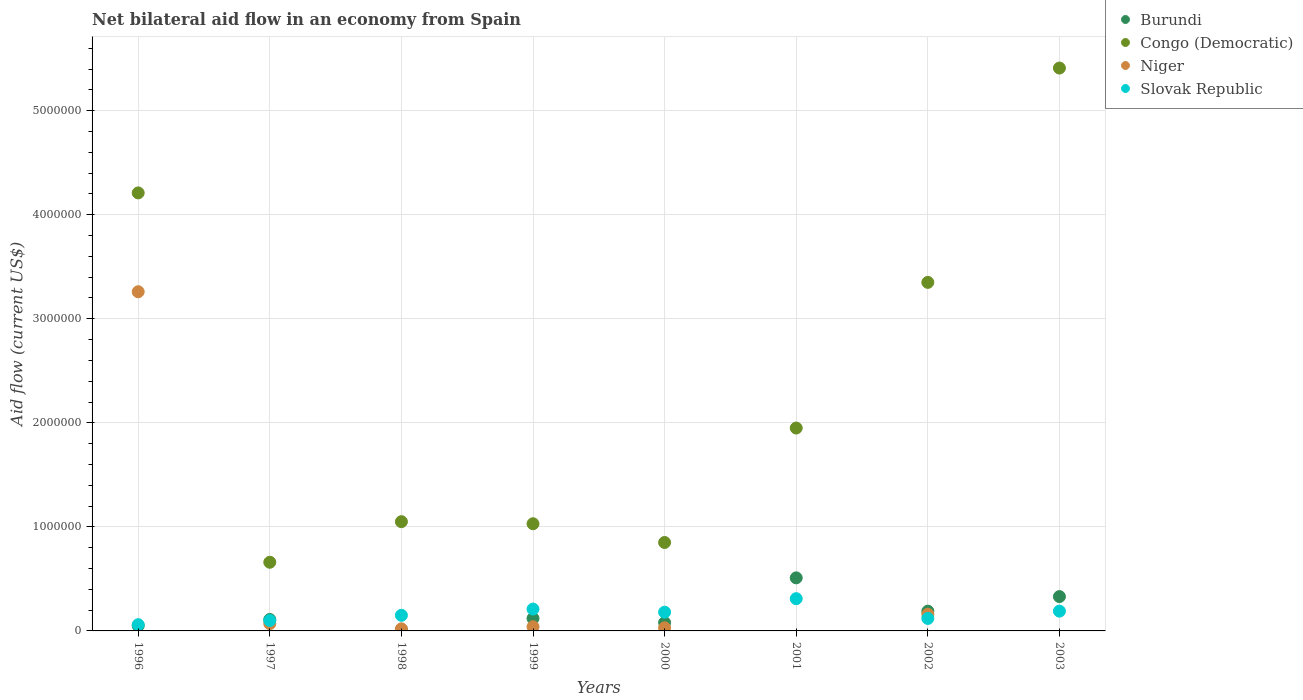Is the number of dotlines equal to the number of legend labels?
Your answer should be very brief. No. Across all years, what is the maximum net bilateral aid flow in Niger?
Offer a terse response. 3.26e+06. What is the total net bilateral aid flow in Congo (Democratic) in the graph?
Offer a very short reply. 1.85e+07. What is the difference between the net bilateral aid flow in Congo (Democratic) in 1998 and that in 1999?
Offer a terse response. 2.00e+04. What is the average net bilateral aid flow in Slovak Republic per year?
Provide a succinct answer. 1.65e+05. In the year 2002, what is the difference between the net bilateral aid flow in Congo (Democratic) and net bilateral aid flow in Burundi?
Your answer should be compact. 3.16e+06. What is the ratio of the net bilateral aid flow in Niger in 1998 to that in 2000?
Give a very brief answer. 0.67. Is the net bilateral aid flow in Slovak Republic in 1996 less than that in 1997?
Your answer should be compact. Yes. Is the difference between the net bilateral aid flow in Congo (Democratic) in 1996 and 1997 greater than the difference between the net bilateral aid flow in Burundi in 1996 and 1997?
Provide a short and direct response. Yes. What is the difference between the highest and the second highest net bilateral aid flow in Congo (Democratic)?
Provide a short and direct response. 1.20e+06. What is the difference between the highest and the lowest net bilateral aid flow in Niger?
Provide a succinct answer. 3.26e+06. Is the sum of the net bilateral aid flow in Niger in 1996 and 2000 greater than the maximum net bilateral aid flow in Congo (Democratic) across all years?
Offer a very short reply. No. Is the net bilateral aid flow in Burundi strictly greater than the net bilateral aid flow in Niger over the years?
Your answer should be compact. No. How many dotlines are there?
Make the answer very short. 4. What is the difference between two consecutive major ticks on the Y-axis?
Ensure brevity in your answer.  1.00e+06. Are the values on the major ticks of Y-axis written in scientific E-notation?
Offer a very short reply. No. Does the graph contain grids?
Make the answer very short. Yes. Where does the legend appear in the graph?
Make the answer very short. Top right. How many legend labels are there?
Your answer should be compact. 4. How are the legend labels stacked?
Offer a terse response. Vertical. What is the title of the graph?
Your answer should be very brief. Net bilateral aid flow in an economy from Spain. What is the label or title of the X-axis?
Provide a short and direct response. Years. What is the Aid flow (current US$) in Congo (Democratic) in 1996?
Offer a terse response. 4.21e+06. What is the Aid flow (current US$) of Niger in 1996?
Your answer should be compact. 3.26e+06. What is the Aid flow (current US$) of Niger in 1997?
Make the answer very short. 7.00e+04. What is the Aid flow (current US$) of Slovak Republic in 1997?
Ensure brevity in your answer.  1.00e+05. What is the Aid flow (current US$) in Burundi in 1998?
Offer a terse response. 10000. What is the Aid flow (current US$) of Congo (Democratic) in 1998?
Your answer should be very brief. 1.05e+06. What is the Aid flow (current US$) of Niger in 1998?
Keep it short and to the point. 2.00e+04. What is the Aid flow (current US$) in Burundi in 1999?
Provide a short and direct response. 1.20e+05. What is the Aid flow (current US$) of Congo (Democratic) in 1999?
Give a very brief answer. 1.03e+06. What is the Aid flow (current US$) in Congo (Democratic) in 2000?
Provide a short and direct response. 8.50e+05. What is the Aid flow (current US$) of Burundi in 2001?
Ensure brevity in your answer.  5.10e+05. What is the Aid flow (current US$) of Congo (Democratic) in 2001?
Your answer should be very brief. 1.95e+06. What is the Aid flow (current US$) of Niger in 2001?
Provide a succinct answer. 0. What is the Aid flow (current US$) in Slovak Republic in 2001?
Keep it short and to the point. 3.10e+05. What is the Aid flow (current US$) of Burundi in 2002?
Provide a succinct answer. 1.90e+05. What is the Aid flow (current US$) of Congo (Democratic) in 2002?
Your answer should be very brief. 3.35e+06. What is the Aid flow (current US$) in Niger in 2002?
Your response must be concise. 1.60e+05. What is the Aid flow (current US$) in Slovak Republic in 2002?
Offer a very short reply. 1.20e+05. What is the Aid flow (current US$) of Burundi in 2003?
Keep it short and to the point. 3.30e+05. What is the Aid flow (current US$) of Congo (Democratic) in 2003?
Offer a very short reply. 5.41e+06. Across all years, what is the maximum Aid flow (current US$) in Burundi?
Offer a very short reply. 5.10e+05. Across all years, what is the maximum Aid flow (current US$) of Congo (Democratic)?
Your response must be concise. 5.41e+06. Across all years, what is the maximum Aid flow (current US$) in Niger?
Provide a short and direct response. 3.26e+06. Across all years, what is the maximum Aid flow (current US$) of Slovak Republic?
Give a very brief answer. 3.10e+05. Across all years, what is the minimum Aid flow (current US$) in Burundi?
Give a very brief answer. 10000. Across all years, what is the minimum Aid flow (current US$) in Congo (Democratic)?
Offer a very short reply. 6.60e+05. Across all years, what is the minimum Aid flow (current US$) in Slovak Republic?
Your response must be concise. 6.00e+04. What is the total Aid flow (current US$) in Burundi in the graph?
Your answer should be very brief. 1.40e+06. What is the total Aid flow (current US$) of Congo (Democratic) in the graph?
Your answer should be compact. 1.85e+07. What is the total Aid flow (current US$) of Niger in the graph?
Your answer should be compact. 3.58e+06. What is the total Aid flow (current US$) of Slovak Republic in the graph?
Offer a very short reply. 1.32e+06. What is the difference between the Aid flow (current US$) of Congo (Democratic) in 1996 and that in 1997?
Provide a short and direct response. 3.55e+06. What is the difference between the Aid flow (current US$) of Niger in 1996 and that in 1997?
Your answer should be compact. 3.19e+06. What is the difference between the Aid flow (current US$) in Congo (Democratic) in 1996 and that in 1998?
Your answer should be compact. 3.16e+06. What is the difference between the Aid flow (current US$) in Niger in 1996 and that in 1998?
Make the answer very short. 3.24e+06. What is the difference between the Aid flow (current US$) of Slovak Republic in 1996 and that in 1998?
Give a very brief answer. -9.00e+04. What is the difference between the Aid flow (current US$) in Congo (Democratic) in 1996 and that in 1999?
Provide a short and direct response. 3.18e+06. What is the difference between the Aid flow (current US$) of Niger in 1996 and that in 1999?
Provide a short and direct response. 3.22e+06. What is the difference between the Aid flow (current US$) in Congo (Democratic) in 1996 and that in 2000?
Keep it short and to the point. 3.36e+06. What is the difference between the Aid flow (current US$) of Niger in 1996 and that in 2000?
Provide a short and direct response. 3.23e+06. What is the difference between the Aid flow (current US$) of Burundi in 1996 and that in 2001?
Your answer should be very brief. -4.60e+05. What is the difference between the Aid flow (current US$) of Congo (Democratic) in 1996 and that in 2001?
Give a very brief answer. 2.26e+06. What is the difference between the Aid flow (current US$) in Burundi in 1996 and that in 2002?
Make the answer very short. -1.40e+05. What is the difference between the Aid flow (current US$) of Congo (Democratic) in 1996 and that in 2002?
Make the answer very short. 8.60e+05. What is the difference between the Aid flow (current US$) of Niger in 1996 and that in 2002?
Offer a terse response. 3.10e+06. What is the difference between the Aid flow (current US$) in Slovak Republic in 1996 and that in 2002?
Make the answer very short. -6.00e+04. What is the difference between the Aid flow (current US$) in Burundi in 1996 and that in 2003?
Provide a succinct answer. -2.80e+05. What is the difference between the Aid flow (current US$) of Congo (Democratic) in 1996 and that in 2003?
Keep it short and to the point. -1.20e+06. What is the difference between the Aid flow (current US$) in Slovak Republic in 1996 and that in 2003?
Provide a short and direct response. -1.30e+05. What is the difference between the Aid flow (current US$) of Congo (Democratic) in 1997 and that in 1998?
Ensure brevity in your answer.  -3.90e+05. What is the difference between the Aid flow (current US$) of Niger in 1997 and that in 1998?
Your answer should be compact. 5.00e+04. What is the difference between the Aid flow (current US$) in Burundi in 1997 and that in 1999?
Provide a short and direct response. -10000. What is the difference between the Aid flow (current US$) of Congo (Democratic) in 1997 and that in 1999?
Offer a very short reply. -3.70e+05. What is the difference between the Aid flow (current US$) of Niger in 1997 and that in 1999?
Ensure brevity in your answer.  3.00e+04. What is the difference between the Aid flow (current US$) in Slovak Republic in 1997 and that in 1999?
Give a very brief answer. -1.10e+05. What is the difference between the Aid flow (current US$) in Burundi in 1997 and that in 2001?
Your answer should be compact. -4.00e+05. What is the difference between the Aid flow (current US$) of Congo (Democratic) in 1997 and that in 2001?
Your answer should be very brief. -1.29e+06. What is the difference between the Aid flow (current US$) of Slovak Republic in 1997 and that in 2001?
Offer a terse response. -2.10e+05. What is the difference between the Aid flow (current US$) in Congo (Democratic) in 1997 and that in 2002?
Your response must be concise. -2.69e+06. What is the difference between the Aid flow (current US$) in Niger in 1997 and that in 2002?
Offer a terse response. -9.00e+04. What is the difference between the Aid flow (current US$) in Slovak Republic in 1997 and that in 2002?
Provide a succinct answer. -2.00e+04. What is the difference between the Aid flow (current US$) in Burundi in 1997 and that in 2003?
Your response must be concise. -2.20e+05. What is the difference between the Aid flow (current US$) of Congo (Democratic) in 1997 and that in 2003?
Your response must be concise. -4.75e+06. What is the difference between the Aid flow (current US$) of Congo (Democratic) in 1998 and that in 1999?
Your answer should be compact. 2.00e+04. What is the difference between the Aid flow (current US$) in Niger in 1998 and that in 1999?
Offer a very short reply. -2.00e+04. What is the difference between the Aid flow (current US$) in Slovak Republic in 1998 and that in 1999?
Ensure brevity in your answer.  -6.00e+04. What is the difference between the Aid flow (current US$) of Congo (Democratic) in 1998 and that in 2000?
Make the answer very short. 2.00e+05. What is the difference between the Aid flow (current US$) in Niger in 1998 and that in 2000?
Offer a terse response. -10000. What is the difference between the Aid flow (current US$) of Burundi in 1998 and that in 2001?
Provide a succinct answer. -5.00e+05. What is the difference between the Aid flow (current US$) in Congo (Democratic) in 1998 and that in 2001?
Ensure brevity in your answer.  -9.00e+05. What is the difference between the Aid flow (current US$) in Slovak Republic in 1998 and that in 2001?
Your response must be concise. -1.60e+05. What is the difference between the Aid flow (current US$) in Congo (Democratic) in 1998 and that in 2002?
Offer a terse response. -2.30e+06. What is the difference between the Aid flow (current US$) in Niger in 1998 and that in 2002?
Offer a very short reply. -1.40e+05. What is the difference between the Aid flow (current US$) in Burundi in 1998 and that in 2003?
Keep it short and to the point. -3.20e+05. What is the difference between the Aid flow (current US$) of Congo (Democratic) in 1998 and that in 2003?
Your answer should be very brief. -4.36e+06. What is the difference between the Aid flow (current US$) of Slovak Republic in 1998 and that in 2003?
Ensure brevity in your answer.  -4.00e+04. What is the difference between the Aid flow (current US$) in Congo (Democratic) in 1999 and that in 2000?
Your response must be concise. 1.80e+05. What is the difference between the Aid flow (current US$) in Niger in 1999 and that in 2000?
Ensure brevity in your answer.  10000. What is the difference between the Aid flow (current US$) in Slovak Republic in 1999 and that in 2000?
Provide a succinct answer. 3.00e+04. What is the difference between the Aid flow (current US$) in Burundi in 1999 and that in 2001?
Offer a terse response. -3.90e+05. What is the difference between the Aid flow (current US$) of Congo (Democratic) in 1999 and that in 2001?
Keep it short and to the point. -9.20e+05. What is the difference between the Aid flow (current US$) in Congo (Democratic) in 1999 and that in 2002?
Provide a short and direct response. -2.32e+06. What is the difference between the Aid flow (current US$) in Niger in 1999 and that in 2002?
Your answer should be very brief. -1.20e+05. What is the difference between the Aid flow (current US$) in Slovak Republic in 1999 and that in 2002?
Give a very brief answer. 9.00e+04. What is the difference between the Aid flow (current US$) of Congo (Democratic) in 1999 and that in 2003?
Your answer should be very brief. -4.38e+06. What is the difference between the Aid flow (current US$) in Burundi in 2000 and that in 2001?
Your answer should be compact. -4.30e+05. What is the difference between the Aid flow (current US$) in Congo (Democratic) in 2000 and that in 2001?
Your response must be concise. -1.10e+06. What is the difference between the Aid flow (current US$) of Slovak Republic in 2000 and that in 2001?
Make the answer very short. -1.30e+05. What is the difference between the Aid flow (current US$) in Congo (Democratic) in 2000 and that in 2002?
Make the answer very short. -2.50e+06. What is the difference between the Aid flow (current US$) of Niger in 2000 and that in 2002?
Offer a terse response. -1.30e+05. What is the difference between the Aid flow (current US$) of Burundi in 2000 and that in 2003?
Your answer should be very brief. -2.50e+05. What is the difference between the Aid flow (current US$) in Congo (Democratic) in 2000 and that in 2003?
Give a very brief answer. -4.56e+06. What is the difference between the Aid flow (current US$) of Congo (Democratic) in 2001 and that in 2002?
Give a very brief answer. -1.40e+06. What is the difference between the Aid flow (current US$) of Slovak Republic in 2001 and that in 2002?
Offer a very short reply. 1.90e+05. What is the difference between the Aid flow (current US$) of Burundi in 2001 and that in 2003?
Your response must be concise. 1.80e+05. What is the difference between the Aid flow (current US$) in Congo (Democratic) in 2001 and that in 2003?
Keep it short and to the point. -3.46e+06. What is the difference between the Aid flow (current US$) in Burundi in 2002 and that in 2003?
Keep it short and to the point. -1.40e+05. What is the difference between the Aid flow (current US$) in Congo (Democratic) in 2002 and that in 2003?
Your answer should be very brief. -2.06e+06. What is the difference between the Aid flow (current US$) of Burundi in 1996 and the Aid flow (current US$) of Congo (Democratic) in 1997?
Your answer should be compact. -6.10e+05. What is the difference between the Aid flow (current US$) of Burundi in 1996 and the Aid flow (current US$) of Niger in 1997?
Keep it short and to the point. -2.00e+04. What is the difference between the Aid flow (current US$) of Burundi in 1996 and the Aid flow (current US$) of Slovak Republic in 1997?
Ensure brevity in your answer.  -5.00e+04. What is the difference between the Aid flow (current US$) in Congo (Democratic) in 1996 and the Aid flow (current US$) in Niger in 1997?
Your response must be concise. 4.14e+06. What is the difference between the Aid flow (current US$) of Congo (Democratic) in 1996 and the Aid flow (current US$) of Slovak Republic in 1997?
Your answer should be compact. 4.11e+06. What is the difference between the Aid flow (current US$) of Niger in 1996 and the Aid flow (current US$) of Slovak Republic in 1997?
Your answer should be very brief. 3.16e+06. What is the difference between the Aid flow (current US$) of Burundi in 1996 and the Aid flow (current US$) of Congo (Democratic) in 1998?
Your answer should be very brief. -1.00e+06. What is the difference between the Aid flow (current US$) of Congo (Democratic) in 1996 and the Aid flow (current US$) of Niger in 1998?
Make the answer very short. 4.19e+06. What is the difference between the Aid flow (current US$) in Congo (Democratic) in 1996 and the Aid flow (current US$) in Slovak Republic in 1998?
Offer a terse response. 4.06e+06. What is the difference between the Aid flow (current US$) of Niger in 1996 and the Aid flow (current US$) of Slovak Republic in 1998?
Provide a succinct answer. 3.11e+06. What is the difference between the Aid flow (current US$) in Burundi in 1996 and the Aid flow (current US$) in Congo (Democratic) in 1999?
Ensure brevity in your answer.  -9.80e+05. What is the difference between the Aid flow (current US$) in Burundi in 1996 and the Aid flow (current US$) in Slovak Republic in 1999?
Ensure brevity in your answer.  -1.60e+05. What is the difference between the Aid flow (current US$) of Congo (Democratic) in 1996 and the Aid flow (current US$) of Niger in 1999?
Provide a succinct answer. 4.17e+06. What is the difference between the Aid flow (current US$) of Niger in 1996 and the Aid flow (current US$) of Slovak Republic in 1999?
Your answer should be compact. 3.05e+06. What is the difference between the Aid flow (current US$) in Burundi in 1996 and the Aid flow (current US$) in Congo (Democratic) in 2000?
Provide a short and direct response. -8.00e+05. What is the difference between the Aid flow (current US$) in Congo (Democratic) in 1996 and the Aid flow (current US$) in Niger in 2000?
Offer a terse response. 4.18e+06. What is the difference between the Aid flow (current US$) in Congo (Democratic) in 1996 and the Aid flow (current US$) in Slovak Republic in 2000?
Your answer should be compact. 4.03e+06. What is the difference between the Aid flow (current US$) of Niger in 1996 and the Aid flow (current US$) of Slovak Republic in 2000?
Provide a succinct answer. 3.08e+06. What is the difference between the Aid flow (current US$) of Burundi in 1996 and the Aid flow (current US$) of Congo (Democratic) in 2001?
Your response must be concise. -1.90e+06. What is the difference between the Aid flow (current US$) of Congo (Democratic) in 1996 and the Aid flow (current US$) of Slovak Republic in 2001?
Provide a short and direct response. 3.90e+06. What is the difference between the Aid flow (current US$) of Niger in 1996 and the Aid flow (current US$) of Slovak Republic in 2001?
Provide a succinct answer. 2.95e+06. What is the difference between the Aid flow (current US$) of Burundi in 1996 and the Aid flow (current US$) of Congo (Democratic) in 2002?
Keep it short and to the point. -3.30e+06. What is the difference between the Aid flow (current US$) of Burundi in 1996 and the Aid flow (current US$) of Niger in 2002?
Offer a very short reply. -1.10e+05. What is the difference between the Aid flow (current US$) in Congo (Democratic) in 1996 and the Aid flow (current US$) in Niger in 2002?
Your response must be concise. 4.05e+06. What is the difference between the Aid flow (current US$) in Congo (Democratic) in 1996 and the Aid flow (current US$) in Slovak Republic in 2002?
Provide a short and direct response. 4.09e+06. What is the difference between the Aid flow (current US$) of Niger in 1996 and the Aid flow (current US$) of Slovak Republic in 2002?
Provide a short and direct response. 3.14e+06. What is the difference between the Aid flow (current US$) of Burundi in 1996 and the Aid flow (current US$) of Congo (Democratic) in 2003?
Provide a short and direct response. -5.36e+06. What is the difference between the Aid flow (current US$) in Burundi in 1996 and the Aid flow (current US$) in Slovak Republic in 2003?
Your response must be concise. -1.40e+05. What is the difference between the Aid flow (current US$) in Congo (Democratic) in 1996 and the Aid flow (current US$) in Slovak Republic in 2003?
Make the answer very short. 4.02e+06. What is the difference between the Aid flow (current US$) of Niger in 1996 and the Aid flow (current US$) of Slovak Republic in 2003?
Give a very brief answer. 3.07e+06. What is the difference between the Aid flow (current US$) in Burundi in 1997 and the Aid flow (current US$) in Congo (Democratic) in 1998?
Keep it short and to the point. -9.40e+05. What is the difference between the Aid flow (current US$) of Burundi in 1997 and the Aid flow (current US$) of Slovak Republic in 1998?
Offer a very short reply. -4.00e+04. What is the difference between the Aid flow (current US$) of Congo (Democratic) in 1997 and the Aid flow (current US$) of Niger in 1998?
Provide a succinct answer. 6.40e+05. What is the difference between the Aid flow (current US$) of Congo (Democratic) in 1997 and the Aid flow (current US$) of Slovak Republic in 1998?
Your answer should be compact. 5.10e+05. What is the difference between the Aid flow (current US$) of Burundi in 1997 and the Aid flow (current US$) of Congo (Democratic) in 1999?
Make the answer very short. -9.20e+05. What is the difference between the Aid flow (current US$) of Congo (Democratic) in 1997 and the Aid flow (current US$) of Niger in 1999?
Offer a very short reply. 6.20e+05. What is the difference between the Aid flow (current US$) of Niger in 1997 and the Aid flow (current US$) of Slovak Republic in 1999?
Your answer should be very brief. -1.40e+05. What is the difference between the Aid flow (current US$) in Burundi in 1997 and the Aid flow (current US$) in Congo (Democratic) in 2000?
Your answer should be very brief. -7.40e+05. What is the difference between the Aid flow (current US$) in Congo (Democratic) in 1997 and the Aid flow (current US$) in Niger in 2000?
Make the answer very short. 6.30e+05. What is the difference between the Aid flow (current US$) of Burundi in 1997 and the Aid flow (current US$) of Congo (Democratic) in 2001?
Give a very brief answer. -1.84e+06. What is the difference between the Aid flow (current US$) of Burundi in 1997 and the Aid flow (current US$) of Slovak Republic in 2001?
Your answer should be very brief. -2.00e+05. What is the difference between the Aid flow (current US$) in Congo (Democratic) in 1997 and the Aid flow (current US$) in Slovak Republic in 2001?
Make the answer very short. 3.50e+05. What is the difference between the Aid flow (current US$) of Niger in 1997 and the Aid flow (current US$) of Slovak Republic in 2001?
Give a very brief answer. -2.40e+05. What is the difference between the Aid flow (current US$) of Burundi in 1997 and the Aid flow (current US$) of Congo (Democratic) in 2002?
Provide a short and direct response. -3.24e+06. What is the difference between the Aid flow (current US$) of Burundi in 1997 and the Aid flow (current US$) of Niger in 2002?
Provide a succinct answer. -5.00e+04. What is the difference between the Aid flow (current US$) in Congo (Democratic) in 1997 and the Aid flow (current US$) in Slovak Republic in 2002?
Give a very brief answer. 5.40e+05. What is the difference between the Aid flow (current US$) in Burundi in 1997 and the Aid flow (current US$) in Congo (Democratic) in 2003?
Your answer should be compact. -5.30e+06. What is the difference between the Aid flow (current US$) in Congo (Democratic) in 1997 and the Aid flow (current US$) in Slovak Republic in 2003?
Provide a short and direct response. 4.70e+05. What is the difference between the Aid flow (current US$) in Niger in 1997 and the Aid flow (current US$) in Slovak Republic in 2003?
Keep it short and to the point. -1.20e+05. What is the difference between the Aid flow (current US$) in Burundi in 1998 and the Aid flow (current US$) in Congo (Democratic) in 1999?
Your answer should be very brief. -1.02e+06. What is the difference between the Aid flow (current US$) in Burundi in 1998 and the Aid flow (current US$) in Niger in 1999?
Your response must be concise. -3.00e+04. What is the difference between the Aid flow (current US$) of Congo (Democratic) in 1998 and the Aid flow (current US$) of Niger in 1999?
Make the answer very short. 1.01e+06. What is the difference between the Aid flow (current US$) in Congo (Democratic) in 1998 and the Aid flow (current US$) in Slovak Republic in 1999?
Offer a terse response. 8.40e+05. What is the difference between the Aid flow (current US$) of Niger in 1998 and the Aid flow (current US$) of Slovak Republic in 1999?
Make the answer very short. -1.90e+05. What is the difference between the Aid flow (current US$) of Burundi in 1998 and the Aid flow (current US$) of Congo (Democratic) in 2000?
Offer a terse response. -8.40e+05. What is the difference between the Aid flow (current US$) in Burundi in 1998 and the Aid flow (current US$) in Slovak Republic in 2000?
Your response must be concise. -1.70e+05. What is the difference between the Aid flow (current US$) in Congo (Democratic) in 1998 and the Aid flow (current US$) in Niger in 2000?
Offer a terse response. 1.02e+06. What is the difference between the Aid flow (current US$) in Congo (Democratic) in 1998 and the Aid flow (current US$) in Slovak Republic in 2000?
Offer a very short reply. 8.70e+05. What is the difference between the Aid flow (current US$) in Burundi in 1998 and the Aid flow (current US$) in Congo (Democratic) in 2001?
Your answer should be very brief. -1.94e+06. What is the difference between the Aid flow (current US$) of Congo (Democratic) in 1998 and the Aid flow (current US$) of Slovak Republic in 2001?
Your answer should be very brief. 7.40e+05. What is the difference between the Aid flow (current US$) of Burundi in 1998 and the Aid flow (current US$) of Congo (Democratic) in 2002?
Keep it short and to the point. -3.34e+06. What is the difference between the Aid flow (current US$) in Burundi in 1998 and the Aid flow (current US$) in Niger in 2002?
Your answer should be very brief. -1.50e+05. What is the difference between the Aid flow (current US$) in Burundi in 1998 and the Aid flow (current US$) in Slovak Republic in 2002?
Keep it short and to the point. -1.10e+05. What is the difference between the Aid flow (current US$) of Congo (Democratic) in 1998 and the Aid flow (current US$) of Niger in 2002?
Your answer should be very brief. 8.90e+05. What is the difference between the Aid flow (current US$) in Congo (Democratic) in 1998 and the Aid flow (current US$) in Slovak Republic in 2002?
Offer a very short reply. 9.30e+05. What is the difference between the Aid flow (current US$) of Burundi in 1998 and the Aid flow (current US$) of Congo (Democratic) in 2003?
Your answer should be compact. -5.40e+06. What is the difference between the Aid flow (current US$) in Burundi in 1998 and the Aid flow (current US$) in Slovak Republic in 2003?
Offer a very short reply. -1.80e+05. What is the difference between the Aid flow (current US$) of Congo (Democratic) in 1998 and the Aid flow (current US$) of Slovak Republic in 2003?
Offer a very short reply. 8.60e+05. What is the difference between the Aid flow (current US$) of Niger in 1998 and the Aid flow (current US$) of Slovak Republic in 2003?
Your answer should be very brief. -1.70e+05. What is the difference between the Aid flow (current US$) of Burundi in 1999 and the Aid flow (current US$) of Congo (Democratic) in 2000?
Your answer should be very brief. -7.30e+05. What is the difference between the Aid flow (current US$) of Burundi in 1999 and the Aid flow (current US$) of Niger in 2000?
Your answer should be compact. 9.00e+04. What is the difference between the Aid flow (current US$) in Burundi in 1999 and the Aid flow (current US$) in Slovak Republic in 2000?
Provide a succinct answer. -6.00e+04. What is the difference between the Aid flow (current US$) of Congo (Democratic) in 1999 and the Aid flow (current US$) of Niger in 2000?
Make the answer very short. 1.00e+06. What is the difference between the Aid flow (current US$) of Congo (Democratic) in 1999 and the Aid flow (current US$) of Slovak Republic in 2000?
Provide a succinct answer. 8.50e+05. What is the difference between the Aid flow (current US$) of Burundi in 1999 and the Aid flow (current US$) of Congo (Democratic) in 2001?
Provide a succinct answer. -1.83e+06. What is the difference between the Aid flow (current US$) in Congo (Democratic) in 1999 and the Aid flow (current US$) in Slovak Republic in 2001?
Your answer should be compact. 7.20e+05. What is the difference between the Aid flow (current US$) in Burundi in 1999 and the Aid flow (current US$) in Congo (Democratic) in 2002?
Give a very brief answer. -3.23e+06. What is the difference between the Aid flow (current US$) in Burundi in 1999 and the Aid flow (current US$) in Niger in 2002?
Give a very brief answer. -4.00e+04. What is the difference between the Aid flow (current US$) of Burundi in 1999 and the Aid flow (current US$) of Slovak Republic in 2002?
Ensure brevity in your answer.  0. What is the difference between the Aid flow (current US$) in Congo (Democratic) in 1999 and the Aid flow (current US$) in Niger in 2002?
Make the answer very short. 8.70e+05. What is the difference between the Aid flow (current US$) of Congo (Democratic) in 1999 and the Aid flow (current US$) of Slovak Republic in 2002?
Ensure brevity in your answer.  9.10e+05. What is the difference between the Aid flow (current US$) of Niger in 1999 and the Aid flow (current US$) of Slovak Republic in 2002?
Your answer should be compact. -8.00e+04. What is the difference between the Aid flow (current US$) in Burundi in 1999 and the Aid flow (current US$) in Congo (Democratic) in 2003?
Your response must be concise. -5.29e+06. What is the difference between the Aid flow (current US$) in Burundi in 1999 and the Aid flow (current US$) in Slovak Republic in 2003?
Make the answer very short. -7.00e+04. What is the difference between the Aid flow (current US$) of Congo (Democratic) in 1999 and the Aid flow (current US$) of Slovak Republic in 2003?
Offer a very short reply. 8.40e+05. What is the difference between the Aid flow (current US$) of Niger in 1999 and the Aid flow (current US$) of Slovak Republic in 2003?
Give a very brief answer. -1.50e+05. What is the difference between the Aid flow (current US$) in Burundi in 2000 and the Aid flow (current US$) in Congo (Democratic) in 2001?
Keep it short and to the point. -1.87e+06. What is the difference between the Aid flow (current US$) in Burundi in 2000 and the Aid flow (current US$) in Slovak Republic in 2001?
Your answer should be compact. -2.30e+05. What is the difference between the Aid flow (current US$) of Congo (Democratic) in 2000 and the Aid flow (current US$) of Slovak Republic in 2001?
Your answer should be very brief. 5.40e+05. What is the difference between the Aid flow (current US$) in Niger in 2000 and the Aid flow (current US$) in Slovak Republic in 2001?
Give a very brief answer. -2.80e+05. What is the difference between the Aid flow (current US$) in Burundi in 2000 and the Aid flow (current US$) in Congo (Democratic) in 2002?
Your answer should be compact. -3.27e+06. What is the difference between the Aid flow (current US$) of Congo (Democratic) in 2000 and the Aid flow (current US$) of Niger in 2002?
Your response must be concise. 6.90e+05. What is the difference between the Aid flow (current US$) in Congo (Democratic) in 2000 and the Aid flow (current US$) in Slovak Republic in 2002?
Your answer should be very brief. 7.30e+05. What is the difference between the Aid flow (current US$) of Burundi in 2000 and the Aid flow (current US$) of Congo (Democratic) in 2003?
Provide a succinct answer. -5.33e+06. What is the difference between the Aid flow (current US$) in Congo (Democratic) in 2000 and the Aid flow (current US$) in Slovak Republic in 2003?
Ensure brevity in your answer.  6.60e+05. What is the difference between the Aid flow (current US$) of Burundi in 2001 and the Aid flow (current US$) of Congo (Democratic) in 2002?
Your answer should be compact. -2.84e+06. What is the difference between the Aid flow (current US$) of Congo (Democratic) in 2001 and the Aid flow (current US$) of Niger in 2002?
Make the answer very short. 1.79e+06. What is the difference between the Aid flow (current US$) in Congo (Democratic) in 2001 and the Aid flow (current US$) in Slovak Republic in 2002?
Keep it short and to the point. 1.83e+06. What is the difference between the Aid flow (current US$) in Burundi in 2001 and the Aid flow (current US$) in Congo (Democratic) in 2003?
Provide a succinct answer. -4.90e+06. What is the difference between the Aid flow (current US$) of Burundi in 2001 and the Aid flow (current US$) of Slovak Republic in 2003?
Ensure brevity in your answer.  3.20e+05. What is the difference between the Aid flow (current US$) of Congo (Democratic) in 2001 and the Aid flow (current US$) of Slovak Republic in 2003?
Your answer should be very brief. 1.76e+06. What is the difference between the Aid flow (current US$) in Burundi in 2002 and the Aid flow (current US$) in Congo (Democratic) in 2003?
Keep it short and to the point. -5.22e+06. What is the difference between the Aid flow (current US$) of Burundi in 2002 and the Aid flow (current US$) of Slovak Republic in 2003?
Your answer should be very brief. 0. What is the difference between the Aid flow (current US$) of Congo (Democratic) in 2002 and the Aid flow (current US$) of Slovak Republic in 2003?
Offer a terse response. 3.16e+06. What is the difference between the Aid flow (current US$) of Niger in 2002 and the Aid flow (current US$) of Slovak Republic in 2003?
Your answer should be very brief. -3.00e+04. What is the average Aid flow (current US$) of Burundi per year?
Offer a very short reply. 1.75e+05. What is the average Aid flow (current US$) in Congo (Democratic) per year?
Offer a terse response. 2.31e+06. What is the average Aid flow (current US$) in Niger per year?
Your answer should be very brief. 4.48e+05. What is the average Aid flow (current US$) in Slovak Republic per year?
Offer a very short reply. 1.65e+05. In the year 1996, what is the difference between the Aid flow (current US$) of Burundi and Aid flow (current US$) of Congo (Democratic)?
Your answer should be very brief. -4.16e+06. In the year 1996, what is the difference between the Aid flow (current US$) of Burundi and Aid flow (current US$) of Niger?
Keep it short and to the point. -3.21e+06. In the year 1996, what is the difference between the Aid flow (current US$) in Burundi and Aid flow (current US$) in Slovak Republic?
Provide a short and direct response. -10000. In the year 1996, what is the difference between the Aid flow (current US$) in Congo (Democratic) and Aid flow (current US$) in Niger?
Offer a terse response. 9.50e+05. In the year 1996, what is the difference between the Aid flow (current US$) in Congo (Democratic) and Aid flow (current US$) in Slovak Republic?
Offer a very short reply. 4.15e+06. In the year 1996, what is the difference between the Aid flow (current US$) of Niger and Aid flow (current US$) of Slovak Republic?
Ensure brevity in your answer.  3.20e+06. In the year 1997, what is the difference between the Aid flow (current US$) of Burundi and Aid flow (current US$) of Congo (Democratic)?
Your answer should be very brief. -5.50e+05. In the year 1997, what is the difference between the Aid flow (current US$) of Burundi and Aid flow (current US$) of Niger?
Offer a very short reply. 4.00e+04. In the year 1997, what is the difference between the Aid flow (current US$) in Congo (Democratic) and Aid flow (current US$) in Niger?
Keep it short and to the point. 5.90e+05. In the year 1997, what is the difference between the Aid flow (current US$) of Congo (Democratic) and Aid flow (current US$) of Slovak Republic?
Keep it short and to the point. 5.60e+05. In the year 1997, what is the difference between the Aid flow (current US$) of Niger and Aid flow (current US$) of Slovak Republic?
Keep it short and to the point. -3.00e+04. In the year 1998, what is the difference between the Aid flow (current US$) in Burundi and Aid flow (current US$) in Congo (Democratic)?
Make the answer very short. -1.04e+06. In the year 1998, what is the difference between the Aid flow (current US$) in Burundi and Aid flow (current US$) in Niger?
Your response must be concise. -10000. In the year 1998, what is the difference between the Aid flow (current US$) of Burundi and Aid flow (current US$) of Slovak Republic?
Keep it short and to the point. -1.40e+05. In the year 1998, what is the difference between the Aid flow (current US$) of Congo (Democratic) and Aid flow (current US$) of Niger?
Your response must be concise. 1.03e+06. In the year 1999, what is the difference between the Aid flow (current US$) of Burundi and Aid flow (current US$) of Congo (Democratic)?
Offer a terse response. -9.10e+05. In the year 1999, what is the difference between the Aid flow (current US$) in Burundi and Aid flow (current US$) in Slovak Republic?
Offer a very short reply. -9.00e+04. In the year 1999, what is the difference between the Aid flow (current US$) of Congo (Democratic) and Aid flow (current US$) of Niger?
Offer a terse response. 9.90e+05. In the year 1999, what is the difference between the Aid flow (current US$) in Congo (Democratic) and Aid flow (current US$) in Slovak Republic?
Your response must be concise. 8.20e+05. In the year 1999, what is the difference between the Aid flow (current US$) in Niger and Aid flow (current US$) in Slovak Republic?
Offer a terse response. -1.70e+05. In the year 2000, what is the difference between the Aid flow (current US$) in Burundi and Aid flow (current US$) in Congo (Democratic)?
Your response must be concise. -7.70e+05. In the year 2000, what is the difference between the Aid flow (current US$) in Burundi and Aid flow (current US$) in Niger?
Give a very brief answer. 5.00e+04. In the year 2000, what is the difference between the Aid flow (current US$) of Congo (Democratic) and Aid flow (current US$) of Niger?
Provide a succinct answer. 8.20e+05. In the year 2000, what is the difference between the Aid flow (current US$) of Congo (Democratic) and Aid flow (current US$) of Slovak Republic?
Your response must be concise. 6.70e+05. In the year 2000, what is the difference between the Aid flow (current US$) in Niger and Aid flow (current US$) in Slovak Republic?
Your response must be concise. -1.50e+05. In the year 2001, what is the difference between the Aid flow (current US$) of Burundi and Aid flow (current US$) of Congo (Democratic)?
Keep it short and to the point. -1.44e+06. In the year 2001, what is the difference between the Aid flow (current US$) in Congo (Democratic) and Aid flow (current US$) in Slovak Republic?
Keep it short and to the point. 1.64e+06. In the year 2002, what is the difference between the Aid flow (current US$) of Burundi and Aid flow (current US$) of Congo (Democratic)?
Your response must be concise. -3.16e+06. In the year 2002, what is the difference between the Aid flow (current US$) in Burundi and Aid flow (current US$) in Slovak Republic?
Your answer should be very brief. 7.00e+04. In the year 2002, what is the difference between the Aid flow (current US$) in Congo (Democratic) and Aid flow (current US$) in Niger?
Offer a very short reply. 3.19e+06. In the year 2002, what is the difference between the Aid flow (current US$) in Congo (Democratic) and Aid flow (current US$) in Slovak Republic?
Offer a very short reply. 3.23e+06. In the year 2002, what is the difference between the Aid flow (current US$) in Niger and Aid flow (current US$) in Slovak Republic?
Give a very brief answer. 4.00e+04. In the year 2003, what is the difference between the Aid flow (current US$) in Burundi and Aid flow (current US$) in Congo (Democratic)?
Your response must be concise. -5.08e+06. In the year 2003, what is the difference between the Aid flow (current US$) of Burundi and Aid flow (current US$) of Slovak Republic?
Give a very brief answer. 1.40e+05. In the year 2003, what is the difference between the Aid flow (current US$) of Congo (Democratic) and Aid flow (current US$) of Slovak Republic?
Keep it short and to the point. 5.22e+06. What is the ratio of the Aid flow (current US$) of Burundi in 1996 to that in 1997?
Keep it short and to the point. 0.45. What is the ratio of the Aid flow (current US$) in Congo (Democratic) in 1996 to that in 1997?
Ensure brevity in your answer.  6.38. What is the ratio of the Aid flow (current US$) in Niger in 1996 to that in 1997?
Your answer should be compact. 46.57. What is the ratio of the Aid flow (current US$) in Congo (Democratic) in 1996 to that in 1998?
Your answer should be compact. 4.01. What is the ratio of the Aid flow (current US$) of Niger in 1996 to that in 1998?
Offer a very short reply. 163. What is the ratio of the Aid flow (current US$) in Slovak Republic in 1996 to that in 1998?
Provide a short and direct response. 0.4. What is the ratio of the Aid flow (current US$) in Burundi in 1996 to that in 1999?
Ensure brevity in your answer.  0.42. What is the ratio of the Aid flow (current US$) in Congo (Democratic) in 1996 to that in 1999?
Provide a succinct answer. 4.09. What is the ratio of the Aid flow (current US$) of Niger in 1996 to that in 1999?
Keep it short and to the point. 81.5. What is the ratio of the Aid flow (current US$) of Slovak Republic in 1996 to that in 1999?
Your answer should be very brief. 0.29. What is the ratio of the Aid flow (current US$) in Burundi in 1996 to that in 2000?
Provide a short and direct response. 0.62. What is the ratio of the Aid flow (current US$) in Congo (Democratic) in 1996 to that in 2000?
Offer a terse response. 4.95. What is the ratio of the Aid flow (current US$) of Niger in 1996 to that in 2000?
Offer a very short reply. 108.67. What is the ratio of the Aid flow (current US$) of Slovak Republic in 1996 to that in 2000?
Offer a terse response. 0.33. What is the ratio of the Aid flow (current US$) in Burundi in 1996 to that in 2001?
Keep it short and to the point. 0.1. What is the ratio of the Aid flow (current US$) in Congo (Democratic) in 1996 to that in 2001?
Keep it short and to the point. 2.16. What is the ratio of the Aid flow (current US$) of Slovak Republic in 1996 to that in 2001?
Give a very brief answer. 0.19. What is the ratio of the Aid flow (current US$) of Burundi in 1996 to that in 2002?
Ensure brevity in your answer.  0.26. What is the ratio of the Aid flow (current US$) of Congo (Democratic) in 1996 to that in 2002?
Make the answer very short. 1.26. What is the ratio of the Aid flow (current US$) of Niger in 1996 to that in 2002?
Your answer should be compact. 20.38. What is the ratio of the Aid flow (current US$) in Burundi in 1996 to that in 2003?
Your answer should be compact. 0.15. What is the ratio of the Aid flow (current US$) in Congo (Democratic) in 1996 to that in 2003?
Provide a succinct answer. 0.78. What is the ratio of the Aid flow (current US$) in Slovak Republic in 1996 to that in 2003?
Your answer should be very brief. 0.32. What is the ratio of the Aid flow (current US$) of Burundi in 1997 to that in 1998?
Your response must be concise. 11. What is the ratio of the Aid flow (current US$) in Congo (Democratic) in 1997 to that in 1998?
Provide a short and direct response. 0.63. What is the ratio of the Aid flow (current US$) in Niger in 1997 to that in 1998?
Keep it short and to the point. 3.5. What is the ratio of the Aid flow (current US$) of Slovak Republic in 1997 to that in 1998?
Make the answer very short. 0.67. What is the ratio of the Aid flow (current US$) of Congo (Democratic) in 1997 to that in 1999?
Provide a succinct answer. 0.64. What is the ratio of the Aid flow (current US$) of Slovak Republic in 1997 to that in 1999?
Give a very brief answer. 0.48. What is the ratio of the Aid flow (current US$) in Burundi in 1997 to that in 2000?
Your response must be concise. 1.38. What is the ratio of the Aid flow (current US$) in Congo (Democratic) in 1997 to that in 2000?
Keep it short and to the point. 0.78. What is the ratio of the Aid flow (current US$) in Niger in 1997 to that in 2000?
Provide a short and direct response. 2.33. What is the ratio of the Aid flow (current US$) in Slovak Republic in 1997 to that in 2000?
Give a very brief answer. 0.56. What is the ratio of the Aid flow (current US$) in Burundi in 1997 to that in 2001?
Offer a terse response. 0.22. What is the ratio of the Aid flow (current US$) in Congo (Democratic) in 1997 to that in 2001?
Your answer should be compact. 0.34. What is the ratio of the Aid flow (current US$) in Slovak Republic in 1997 to that in 2001?
Your answer should be compact. 0.32. What is the ratio of the Aid flow (current US$) of Burundi in 1997 to that in 2002?
Provide a succinct answer. 0.58. What is the ratio of the Aid flow (current US$) of Congo (Democratic) in 1997 to that in 2002?
Ensure brevity in your answer.  0.2. What is the ratio of the Aid flow (current US$) of Niger in 1997 to that in 2002?
Ensure brevity in your answer.  0.44. What is the ratio of the Aid flow (current US$) in Slovak Republic in 1997 to that in 2002?
Keep it short and to the point. 0.83. What is the ratio of the Aid flow (current US$) of Burundi in 1997 to that in 2003?
Ensure brevity in your answer.  0.33. What is the ratio of the Aid flow (current US$) in Congo (Democratic) in 1997 to that in 2003?
Your answer should be compact. 0.12. What is the ratio of the Aid flow (current US$) of Slovak Republic in 1997 to that in 2003?
Offer a terse response. 0.53. What is the ratio of the Aid flow (current US$) in Burundi in 1998 to that in 1999?
Your answer should be very brief. 0.08. What is the ratio of the Aid flow (current US$) in Congo (Democratic) in 1998 to that in 1999?
Your answer should be very brief. 1.02. What is the ratio of the Aid flow (current US$) in Congo (Democratic) in 1998 to that in 2000?
Provide a short and direct response. 1.24. What is the ratio of the Aid flow (current US$) of Slovak Republic in 1998 to that in 2000?
Provide a short and direct response. 0.83. What is the ratio of the Aid flow (current US$) in Burundi in 1998 to that in 2001?
Provide a short and direct response. 0.02. What is the ratio of the Aid flow (current US$) of Congo (Democratic) in 1998 to that in 2001?
Provide a succinct answer. 0.54. What is the ratio of the Aid flow (current US$) in Slovak Republic in 1998 to that in 2001?
Keep it short and to the point. 0.48. What is the ratio of the Aid flow (current US$) in Burundi in 1998 to that in 2002?
Ensure brevity in your answer.  0.05. What is the ratio of the Aid flow (current US$) in Congo (Democratic) in 1998 to that in 2002?
Keep it short and to the point. 0.31. What is the ratio of the Aid flow (current US$) in Slovak Republic in 1998 to that in 2002?
Keep it short and to the point. 1.25. What is the ratio of the Aid flow (current US$) of Burundi in 1998 to that in 2003?
Offer a very short reply. 0.03. What is the ratio of the Aid flow (current US$) in Congo (Democratic) in 1998 to that in 2003?
Provide a short and direct response. 0.19. What is the ratio of the Aid flow (current US$) of Slovak Republic in 1998 to that in 2003?
Your answer should be compact. 0.79. What is the ratio of the Aid flow (current US$) in Congo (Democratic) in 1999 to that in 2000?
Offer a very short reply. 1.21. What is the ratio of the Aid flow (current US$) in Slovak Republic in 1999 to that in 2000?
Provide a succinct answer. 1.17. What is the ratio of the Aid flow (current US$) of Burundi in 1999 to that in 2001?
Provide a succinct answer. 0.24. What is the ratio of the Aid flow (current US$) in Congo (Democratic) in 1999 to that in 2001?
Make the answer very short. 0.53. What is the ratio of the Aid flow (current US$) of Slovak Republic in 1999 to that in 2001?
Provide a short and direct response. 0.68. What is the ratio of the Aid flow (current US$) in Burundi in 1999 to that in 2002?
Provide a short and direct response. 0.63. What is the ratio of the Aid flow (current US$) of Congo (Democratic) in 1999 to that in 2002?
Your answer should be very brief. 0.31. What is the ratio of the Aid flow (current US$) of Burundi in 1999 to that in 2003?
Your answer should be very brief. 0.36. What is the ratio of the Aid flow (current US$) in Congo (Democratic) in 1999 to that in 2003?
Give a very brief answer. 0.19. What is the ratio of the Aid flow (current US$) in Slovak Republic in 1999 to that in 2003?
Your response must be concise. 1.11. What is the ratio of the Aid flow (current US$) in Burundi in 2000 to that in 2001?
Ensure brevity in your answer.  0.16. What is the ratio of the Aid flow (current US$) of Congo (Democratic) in 2000 to that in 2001?
Offer a very short reply. 0.44. What is the ratio of the Aid flow (current US$) in Slovak Republic in 2000 to that in 2001?
Give a very brief answer. 0.58. What is the ratio of the Aid flow (current US$) of Burundi in 2000 to that in 2002?
Keep it short and to the point. 0.42. What is the ratio of the Aid flow (current US$) in Congo (Democratic) in 2000 to that in 2002?
Provide a succinct answer. 0.25. What is the ratio of the Aid flow (current US$) in Niger in 2000 to that in 2002?
Make the answer very short. 0.19. What is the ratio of the Aid flow (current US$) of Burundi in 2000 to that in 2003?
Offer a very short reply. 0.24. What is the ratio of the Aid flow (current US$) in Congo (Democratic) in 2000 to that in 2003?
Make the answer very short. 0.16. What is the ratio of the Aid flow (current US$) in Slovak Republic in 2000 to that in 2003?
Offer a terse response. 0.95. What is the ratio of the Aid flow (current US$) of Burundi in 2001 to that in 2002?
Give a very brief answer. 2.68. What is the ratio of the Aid flow (current US$) of Congo (Democratic) in 2001 to that in 2002?
Provide a short and direct response. 0.58. What is the ratio of the Aid flow (current US$) in Slovak Republic in 2001 to that in 2002?
Make the answer very short. 2.58. What is the ratio of the Aid flow (current US$) in Burundi in 2001 to that in 2003?
Make the answer very short. 1.55. What is the ratio of the Aid flow (current US$) of Congo (Democratic) in 2001 to that in 2003?
Offer a terse response. 0.36. What is the ratio of the Aid flow (current US$) in Slovak Republic in 2001 to that in 2003?
Your response must be concise. 1.63. What is the ratio of the Aid flow (current US$) of Burundi in 2002 to that in 2003?
Ensure brevity in your answer.  0.58. What is the ratio of the Aid flow (current US$) in Congo (Democratic) in 2002 to that in 2003?
Make the answer very short. 0.62. What is the ratio of the Aid flow (current US$) of Slovak Republic in 2002 to that in 2003?
Make the answer very short. 0.63. What is the difference between the highest and the second highest Aid flow (current US$) of Burundi?
Offer a very short reply. 1.80e+05. What is the difference between the highest and the second highest Aid flow (current US$) in Congo (Democratic)?
Make the answer very short. 1.20e+06. What is the difference between the highest and the second highest Aid flow (current US$) of Niger?
Your response must be concise. 3.10e+06. What is the difference between the highest and the lowest Aid flow (current US$) of Congo (Democratic)?
Provide a short and direct response. 4.75e+06. What is the difference between the highest and the lowest Aid flow (current US$) of Niger?
Offer a terse response. 3.26e+06. What is the difference between the highest and the lowest Aid flow (current US$) in Slovak Republic?
Keep it short and to the point. 2.50e+05. 